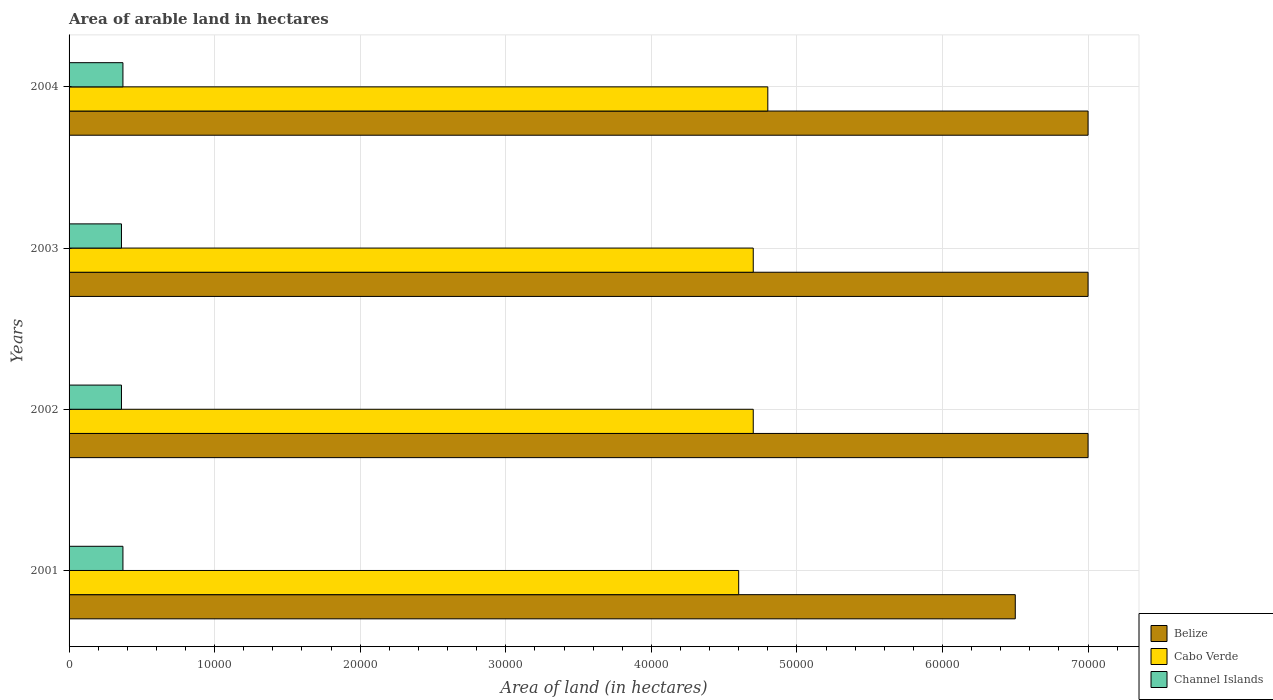How many groups of bars are there?
Keep it short and to the point. 4. Are the number of bars on each tick of the Y-axis equal?
Offer a very short reply. Yes. How many bars are there on the 2nd tick from the top?
Your answer should be compact. 3. How many bars are there on the 1st tick from the bottom?
Keep it short and to the point. 3. What is the label of the 3rd group of bars from the top?
Your response must be concise. 2002. In how many cases, is the number of bars for a given year not equal to the number of legend labels?
Give a very brief answer. 0. What is the total arable land in Cabo Verde in 2004?
Offer a very short reply. 4.80e+04. Across all years, what is the maximum total arable land in Cabo Verde?
Your answer should be very brief. 4.80e+04. Across all years, what is the minimum total arable land in Channel Islands?
Keep it short and to the point. 3600. In which year was the total arable land in Cabo Verde minimum?
Keep it short and to the point. 2001. What is the total total arable land in Channel Islands in the graph?
Provide a succinct answer. 1.46e+04. What is the difference between the total arable land in Cabo Verde in 2001 and that in 2003?
Your answer should be compact. -1000. What is the difference between the total arable land in Cabo Verde in 2001 and the total arable land in Belize in 2003?
Give a very brief answer. -2.40e+04. What is the average total arable land in Cabo Verde per year?
Your response must be concise. 4.70e+04. In the year 2004, what is the difference between the total arable land in Belize and total arable land in Cabo Verde?
Provide a succinct answer. 2.20e+04. What is the ratio of the total arable land in Cabo Verde in 2002 to that in 2004?
Your answer should be compact. 0.98. Is the total arable land in Belize in 2001 less than that in 2002?
Provide a short and direct response. Yes. What is the difference between the highest and the second highest total arable land in Belize?
Your answer should be compact. 0. What is the difference between the highest and the lowest total arable land in Channel Islands?
Provide a succinct answer. 100. What does the 3rd bar from the top in 2002 represents?
Your response must be concise. Belize. What does the 3rd bar from the bottom in 2004 represents?
Ensure brevity in your answer.  Channel Islands. Is it the case that in every year, the sum of the total arable land in Channel Islands and total arable land in Belize is greater than the total arable land in Cabo Verde?
Provide a succinct answer. Yes. How many bars are there?
Give a very brief answer. 12. Are all the bars in the graph horizontal?
Offer a terse response. Yes. Are the values on the major ticks of X-axis written in scientific E-notation?
Your answer should be compact. No. Does the graph contain grids?
Your answer should be very brief. Yes. Where does the legend appear in the graph?
Offer a terse response. Bottom right. How many legend labels are there?
Keep it short and to the point. 3. How are the legend labels stacked?
Provide a succinct answer. Vertical. What is the title of the graph?
Provide a short and direct response. Area of arable land in hectares. Does "Vanuatu" appear as one of the legend labels in the graph?
Provide a short and direct response. No. What is the label or title of the X-axis?
Your answer should be very brief. Area of land (in hectares). What is the Area of land (in hectares) in Belize in 2001?
Your response must be concise. 6.50e+04. What is the Area of land (in hectares) of Cabo Verde in 2001?
Ensure brevity in your answer.  4.60e+04. What is the Area of land (in hectares) of Channel Islands in 2001?
Provide a short and direct response. 3700. What is the Area of land (in hectares) in Belize in 2002?
Provide a short and direct response. 7.00e+04. What is the Area of land (in hectares) in Cabo Verde in 2002?
Give a very brief answer. 4.70e+04. What is the Area of land (in hectares) of Channel Islands in 2002?
Offer a very short reply. 3600. What is the Area of land (in hectares) of Cabo Verde in 2003?
Give a very brief answer. 4.70e+04. What is the Area of land (in hectares) of Channel Islands in 2003?
Ensure brevity in your answer.  3600. What is the Area of land (in hectares) of Cabo Verde in 2004?
Keep it short and to the point. 4.80e+04. What is the Area of land (in hectares) of Channel Islands in 2004?
Give a very brief answer. 3700. Across all years, what is the maximum Area of land (in hectares) in Cabo Verde?
Offer a very short reply. 4.80e+04. Across all years, what is the maximum Area of land (in hectares) of Channel Islands?
Make the answer very short. 3700. Across all years, what is the minimum Area of land (in hectares) of Belize?
Offer a terse response. 6.50e+04. Across all years, what is the minimum Area of land (in hectares) in Cabo Verde?
Your answer should be compact. 4.60e+04. Across all years, what is the minimum Area of land (in hectares) in Channel Islands?
Offer a very short reply. 3600. What is the total Area of land (in hectares) of Belize in the graph?
Your response must be concise. 2.75e+05. What is the total Area of land (in hectares) of Cabo Verde in the graph?
Provide a short and direct response. 1.88e+05. What is the total Area of land (in hectares) of Channel Islands in the graph?
Provide a succinct answer. 1.46e+04. What is the difference between the Area of land (in hectares) in Belize in 2001 and that in 2002?
Offer a terse response. -5000. What is the difference between the Area of land (in hectares) of Cabo Verde in 2001 and that in 2002?
Make the answer very short. -1000. What is the difference between the Area of land (in hectares) of Belize in 2001 and that in 2003?
Your answer should be compact. -5000. What is the difference between the Area of land (in hectares) of Cabo Verde in 2001 and that in 2003?
Your response must be concise. -1000. What is the difference between the Area of land (in hectares) of Channel Islands in 2001 and that in 2003?
Your answer should be compact. 100. What is the difference between the Area of land (in hectares) of Belize in 2001 and that in 2004?
Offer a very short reply. -5000. What is the difference between the Area of land (in hectares) of Cabo Verde in 2001 and that in 2004?
Your answer should be very brief. -2000. What is the difference between the Area of land (in hectares) of Belize in 2002 and that in 2003?
Your response must be concise. 0. What is the difference between the Area of land (in hectares) in Cabo Verde in 2002 and that in 2003?
Keep it short and to the point. 0. What is the difference between the Area of land (in hectares) in Channel Islands in 2002 and that in 2003?
Keep it short and to the point. 0. What is the difference between the Area of land (in hectares) of Belize in 2002 and that in 2004?
Provide a succinct answer. 0. What is the difference between the Area of land (in hectares) of Cabo Verde in 2002 and that in 2004?
Offer a very short reply. -1000. What is the difference between the Area of land (in hectares) of Channel Islands in 2002 and that in 2004?
Provide a succinct answer. -100. What is the difference between the Area of land (in hectares) in Belize in 2003 and that in 2004?
Your answer should be compact. 0. What is the difference between the Area of land (in hectares) in Cabo Verde in 2003 and that in 2004?
Offer a very short reply. -1000. What is the difference between the Area of land (in hectares) in Channel Islands in 2003 and that in 2004?
Offer a terse response. -100. What is the difference between the Area of land (in hectares) in Belize in 2001 and the Area of land (in hectares) in Cabo Verde in 2002?
Provide a succinct answer. 1.80e+04. What is the difference between the Area of land (in hectares) of Belize in 2001 and the Area of land (in hectares) of Channel Islands in 2002?
Your answer should be compact. 6.14e+04. What is the difference between the Area of land (in hectares) in Cabo Verde in 2001 and the Area of land (in hectares) in Channel Islands in 2002?
Ensure brevity in your answer.  4.24e+04. What is the difference between the Area of land (in hectares) of Belize in 2001 and the Area of land (in hectares) of Cabo Verde in 2003?
Your response must be concise. 1.80e+04. What is the difference between the Area of land (in hectares) in Belize in 2001 and the Area of land (in hectares) in Channel Islands in 2003?
Your answer should be very brief. 6.14e+04. What is the difference between the Area of land (in hectares) in Cabo Verde in 2001 and the Area of land (in hectares) in Channel Islands in 2003?
Offer a terse response. 4.24e+04. What is the difference between the Area of land (in hectares) of Belize in 2001 and the Area of land (in hectares) of Cabo Verde in 2004?
Give a very brief answer. 1.70e+04. What is the difference between the Area of land (in hectares) of Belize in 2001 and the Area of land (in hectares) of Channel Islands in 2004?
Provide a short and direct response. 6.13e+04. What is the difference between the Area of land (in hectares) in Cabo Verde in 2001 and the Area of land (in hectares) in Channel Islands in 2004?
Keep it short and to the point. 4.23e+04. What is the difference between the Area of land (in hectares) in Belize in 2002 and the Area of land (in hectares) in Cabo Verde in 2003?
Your answer should be very brief. 2.30e+04. What is the difference between the Area of land (in hectares) in Belize in 2002 and the Area of land (in hectares) in Channel Islands in 2003?
Provide a short and direct response. 6.64e+04. What is the difference between the Area of land (in hectares) of Cabo Verde in 2002 and the Area of land (in hectares) of Channel Islands in 2003?
Keep it short and to the point. 4.34e+04. What is the difference between the Area of land (in hectares) in Belize in 2002 and the Area of land (in hectares) in Cabo Verde in 2004?
Your response must be concise. 2.20e+04. What is the difference between the Area of land (in hectares) of Belize in 2002 and the Area of land (in hectares) of Channel Islands in 2004?
Your response must be concise. 6.63e+04. What is the difference between the Area of land (in hectares) of Cabo Verde in 2002 and the Area of land (in hectares) of Channel Islands in 2004?
Your answer should be compact. 4.33e+04. What is the difference between the Area of land (in hectares) in Belize in 2003 and the Area of land (in hectares) in Cabo Verde in 2004?
Keep it short and to the point. 2.20e+04. What is the difference between the Area of land (in hectares) in Belize in 2003 and the Area of land (in hectares) in Channel Islands in 2004?
Provide a succinct answer. 6.63e+04. What is the difference between the Area of land (in hectares) in Cabo Verde in 2003 and the Area of land (in hectares) in Channel Islands in 2004?
Ensure brevity in your answer.  4.33e+04. What is the average Area of land (in hectares) in Belize per year?
Provide a short and direct response. 6.88e+04. What is the average Area of land (in hectares) of Cabo Verde per year?
Your answer should be very brief. 4.70e+04. What is the average Area of land (in hectares) in Channel Islands per year?
Offer a terse response. 3650. In the year 2001, what is the difference between the Area of land (in hectares) in Belize and Area of land (in hectares) in Cabo Verde?
Give a very brief answer. 1.90e+04. In the year 2001, what is the difference between the Area of land (in hectares) in Belize and Area of land (in hectares) in Channel Islands?
Ensure brevity in your answer.  6.13e+04. In the year 2001, what is the difference between the Area of land (in hectares) in Cabo Verde and Area of land (in hectares) in Channel Islands?
Your response must be concise. 4.23e+04. In the year 2002, what is the difference between the Area of land (in hectares) of Belize and Area of land (in hectares) of Cabo Verde?
Offer a very short reply. 2.30e+04. In the year 2002, what is the difference between the Area of land (in hectares) in Belize and Area of land (in hectares) in Channel Islands?
Provide a succinct answer. 6.64e+04. In the year 2002, what is the difference between the Area of land (in hectares) in Cabo Verde and Area of land (in hectares) in Channel Islands?
Provide a succinct answer. 4.34e+04. In the year 2003, what is the difference between the Area of land (in hectares) of Belize and Area of land (in hectares) of Cabo Verde?
Your answer should be compact. 2.30e+04. In the year 2003, what is the difference between the Area of land (in hectares) of Belize and Area of land (in hectares) of Channel Islands?
Ensure brevity in your answer.  6.64e+04. In the year 2003, what is the difference between the Area of land (in hectares) in Cabo Verde and Area of land (in hectares) in Channel Islands?
Your answer should be very brief. 4.34e+04. In the year 2004, what is the difference between the Area of land (in hectares) of Belize and Area of land (in hectares) of Cabo Verde?
Your answer should be very brief. 2.20e+04. In the year 2004, what is the difference between the Area of land (in hectares) in Belize and Area of land (in hectares) in Channel Islands?
Offer a terse response. 6.63e+04. In the year 2004, what is the difference between the Area of land (in hectares) of Cabo Verde and Area of land (in hectares) of Channel Islands?
Ensure brevity in your answer.  4.43e+04. What is the ratio of the Area of land (in hectares) of Belize in 2001 to that in 2002?
Give a very brief answer. 0.93. What is the ratio of the Area of land (in hectares) of Cabo Verde in 2001 to that in 2002?
Ensure brevity in your answer.  0.98. What is the ratio of the Area of land (in hectares) in Channel Islands in 2001 to that in 2002?
Ensure brevity in your answer.  1.03. What is the ratio of the Area of land (in hectares) of Belize in 2001 to that in 2003?
Your answer should be very brief. 0.93. What is the ratio of the Area of land (in hectares) in Cabo Verde in 2001 to that in 2003?
Keep it short and to the point. 0.98. What is the ratio of the Area of land (in hectares) of Channel Islands in 2001 to that in 2003?
Ensure brevity in your answer.  1.03. What is the ratio of the Area of land (in hectares) in Belize in 2001 to that in 2004?
Your answer should be very brief. 0.93. What is the ratio of the Area of land (in hectares) of Cabo Verde in 2001 to that in 2004?
Your response must be concise. 0.96. What is the ratio of the Area of land (in hectares) in Belize in 2002 to that in 2003?
Your response must be concise. 1. What is the ratio of the Area of land (in hectares) of Channel Islands in 2002 to that in 2003?
Offer a very short reply. 1. What is the ratio of the Area of land (in hectares) in Cabo Verde in 2002 to that in 2004?
Provide a succinct answer. 0.98. What is the ratio of the Area of land (in hectares) in Belize in 2003 to that in 2004?
Give a very brief answer. 1. What is the ratio of the Area of land (in hectares) of Cabo Verde in 2003 to that in 2004?
Make the answer very short. 0.98. What is the ratio of the Area of land (in hectares) in Channel Islands in 2003 to that in 2004?
Your answer should be compact. 0.97. What is the difference between the highest and the second highest Area of land (in hectares) of Belize?
Give a very brief answer. 0. What is the difference between the highest and the second highest Area of land (in hectares) of Channel Islands?
Ensure brevity in your answer.  0. What is the difference between the highest and the lowest Area of land (in hectares) of Cabo Verde?
Provide a succinct answer. 2000. What is the difference between the highest and the lowest Area of land (in hectares) in Channel Islands?
Your answer should be compact. 100. 